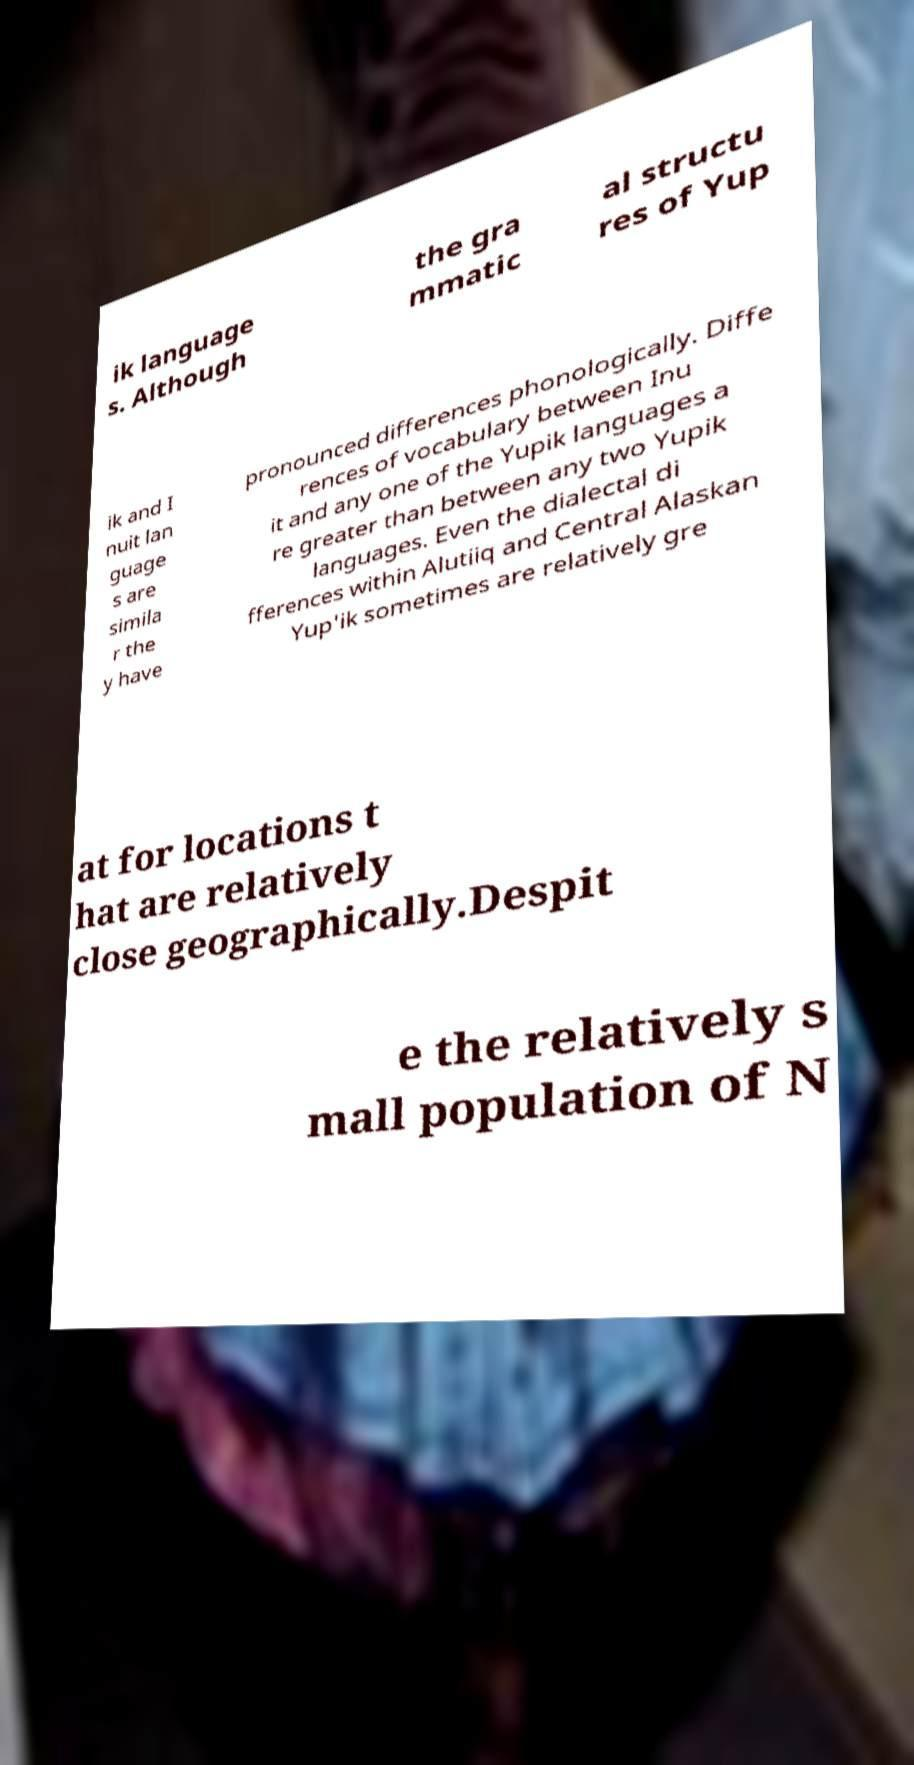Can you accurately transcribe the text from the provided image for me? ik language s. Although the gra mmatic al structu res of Yup ik and I nuit lan guage s are simila r the y have pronounced differences phonologically. Diffe rences of vocabulary between Inu it and any one of the Yupik languages a re greater than between any two Yupik languages. Even the dialectal di fferences within Alutiiq and Central Alaskan Yup'ik sometimes are relatively gre at for locations t hat are relatively close geographically.Despit e the relatively s mall population of N 